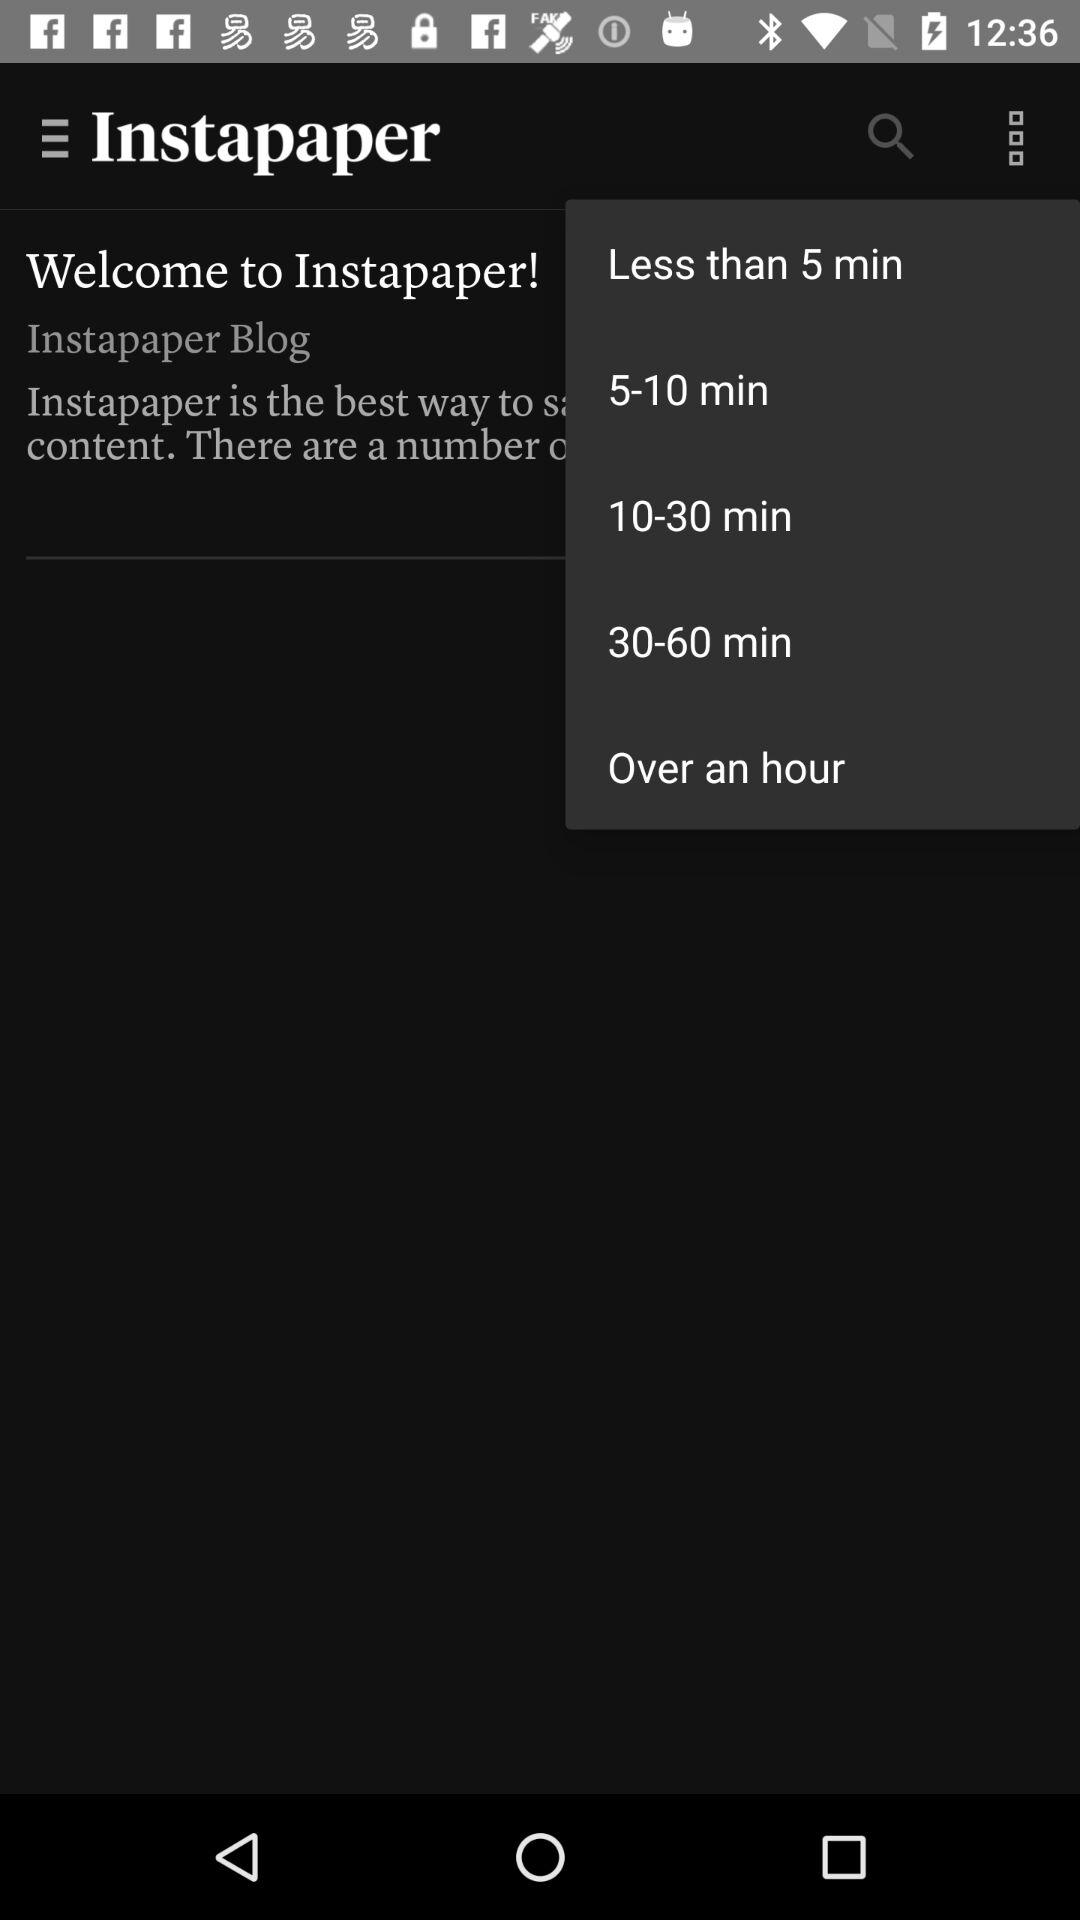What is the name of the application? The name of the application is "Instapaper". 